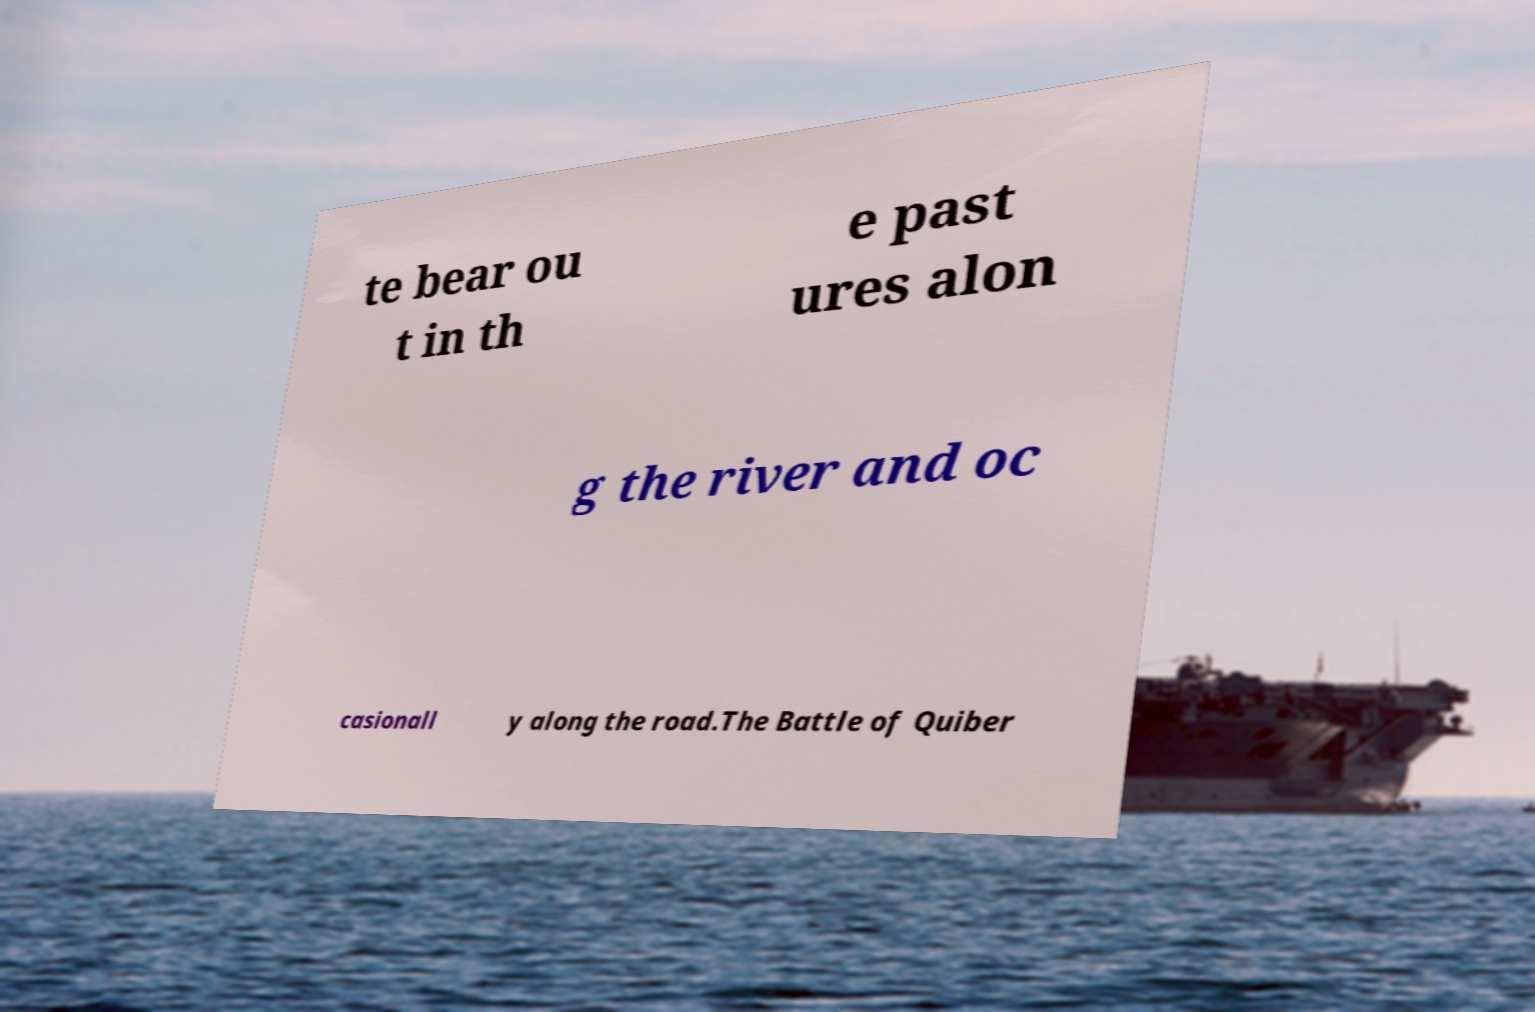Can you accurately transcribe the text from the provided image for me? te bear ou t in th e past ures alon g the river and oc casionall y along the road.The Battle of Quiber 